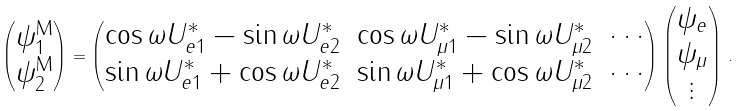Convert formula to latex. <formula><loc_0><loc_0><loc_500><loc_500>\begin{pmatrix} \psi ^ { \text {M} } _ { 1 } \\ \psi ^ { \text {M} } _ { 2 } \end{pmatrix} = \begin{pmatrix} \cos \omega U _ { e 1 } ^ { * } - \sin \omega U _ { e 2 } ^ { * } & \cos \omega U _ { \mu 1 } ^ { * } - \sin \omega U _ { \mu 2 } ^ { * } & \cdots \\ \sin \omega U _ { e 1 } ^ { * } + \cos \omega U _ { e 2 } ^ { * } & \sin \omega U _ { \mu 1 } ^ { * } + \cos \omega U _ { \mu 2 } ^ { * } & \cdots \end{pmatrix} \begin{pmatrix} \psi _ { e } \\ \psi _ { \mu } \\ \vdots \end{pmatrix} \, .</formula> 